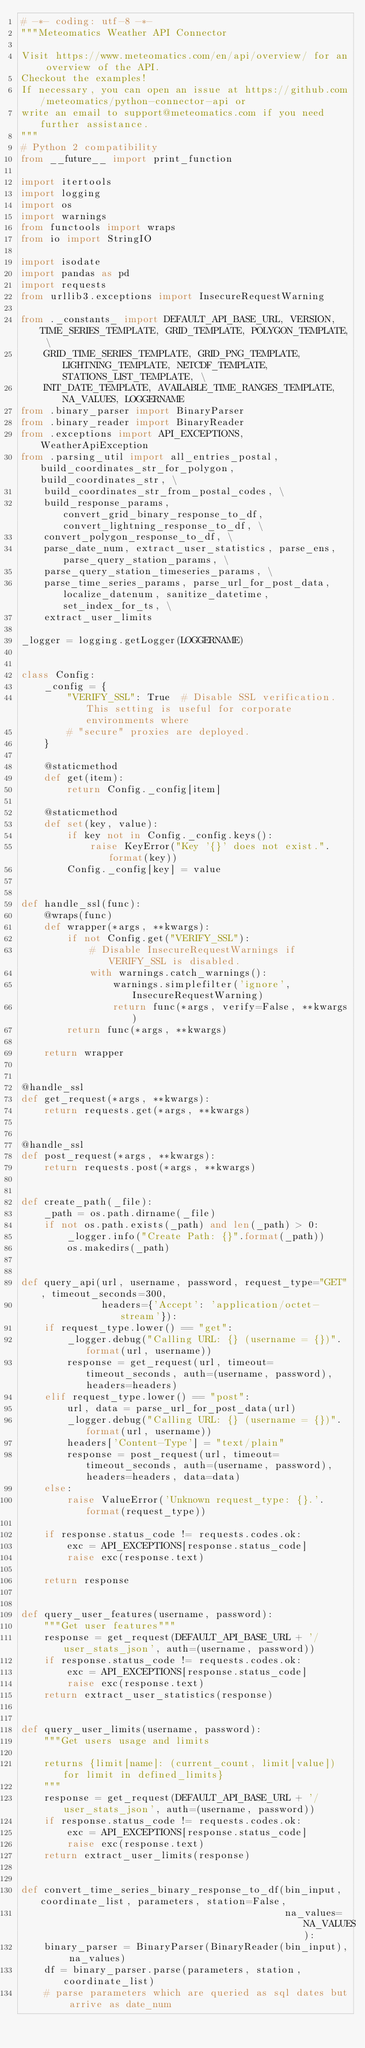<code> <loc_0><loc_0><loc_500><loc_500><_Python_># -*- coding: utf-8 -*-
"""Meteomatics Weather API Connector

Visit https://www.meteomatics.com/en/api/overview/ for an overview of the API.
Checkout the examples!
If necessary, you can open an issue at https://github.com/meteomatics/python-connector-api or
write an email to support@meteomatics.com if you need further assistance.
"""
# Python 2 compatibility
from __future__ import print_function

import itertools
import logging
import os
import warnings
from functools import wraps
from io import StringIO

import isodate
import pandas as pd
import requests
from urllib3.exceptions import InsecureRequestWarning

from ._constants_ import DEFAULT_API_BASE_URL, VERSION, TIME_SERIES_TEMPLATE, GRID_TEMPLATE, POLYGON_TEMPLATE, \
    GRID_TIME_SERIES_TEMPLATE, GRID_PNG_TEMPLATE, LIGHTNING_TEMPLATE, NETCDF_TEMPLATE, STATIONS_LIST_TEMPLATE, \
    INIT_DATE_TEMPLATE, AVAILABLE_TIME_RANGES_TEMPLATE, NA_VALUES, LOGGERNAME
from .binary_parser import BinaryParser
from .binary_reader import BinaryReader
from .exceptions import API_EXCEPTIONS, WeatherApiException
from .parsing_util import all_entries_postal, build_coordinates_str_for_polygon, build_coordinates_str, \
    build_coordinates_str_from_postal_codes, \
    build_response_params, convert_grid_binary_response_to_df, convert_lightning_response_to_df, \
    convert_polygon_response_to_df, \
    parse_date_num, extract_user_statistics, parse_ens, parse_query_station_params, \
    parse_query_station_timeseries_params, \
    parse_time_series_params, parse_url_for_post_data, localize_datenum, sanitize_datetime, set_index_for_ts, \
    extract_user_limits

_logger = logging.getLogger(LOGGERNAME)


class Config:
    _config = {
        "VERIFY_SSL": True  # Disable SSL verification. This setting is useful for corporate environments where
        # "secure" proxies are deployed.
    }

    @staticmethod
    def get(item):
        return Config._config[item]

    @staticmethod
    def set(key, value):
        if key not in Config._config.keys():
            raise KeyError("Key '{}' does not exist.".format(key))
        Config._config[key] = value


def handle_ssl(func):
    @wraps(func)
    def wrapper(*args, **kwargs):
        if not Config.get("VERIFY_SSL"):
            # Disable InsecureRequestWarnings if VERIFY_SSL is disabled.
            with warnings.catch_warnings():
                warnings.simplefilter('ignore', InsecureRequestWarning)
                return func(*args, verify=False, **kwargs)
        return func(*args, **kwargs)

    return wrapper


@handle_ssl
def get_request(*args, **kwargs):
    return requests.get(*args, **kwargs)


@handle_ssl
def post_request(*args, **kwargs):
    return requests.post(*args, **kwargs)


def create_path(_file):
    _path = os.path.dirname(_file)
    if not os.path.exists(_path) and len(_path) > 0:
        _logger.info("Create Path: {}".format(_path))
        os.makedirs(_path)


def query_api(url, username, password, request_type="GET", timeout_seconds=300,
              headers={'Accept': 'application/octet-stream'}):
    if request_type.lower() == "get":
        _logger.debug("Calling URL: {} (username = {})".format(url, username))
        response = get_request(url, timeout=timeout_seconds, auth=(username, password), headers=headers)
    elif request_type.lower() == "post":
        url, data = parse_url_for_post_data(url)
        _logger.debug("Calling URL: {} (username = {})".format(url, username))
        headers['Content-Type'] = "text/plain"
        response = post_request(url, timeout=timeout_seconds, auth=(username, password), headers=headers, data=data)
    else:
        raise ValueError('Unknown request_type: {}.'.format(request_type))

    if response.status_code != requests.codes.ok:
        exc = API_EXCEPTIONS[response.status_code]
        raise exc(response.text)

    return response


def query_user_features(username, password):
    """Get user features"""
    response = get_request(DEFAULT_API_BASE_URL + '/user_stats_json', auth=(username, password))
    if response.status_code != requests.codes.ok:
        exc = API_EXCEPTIONS[response.status_code]
        raise exc(response.text)
    return extract_user_statistics(response)


def query_user_limits(username, password):
    """Get users usage and limits

    returns {limit[name]: (current_count, limit[value]) for limit in defined_limits}
    """
    response = get_request(DEFAULT_API_BASE_URL + '/user_stats_json', auth=(username, password))
    if response.status_code != requests.codes.ok:
        exc = API_EXCEPTIONS[response.status_code]
        raise exc(response.text)
    return extract_user_limits(response)


def convert_time_series_binary_response_to_df(bin_input, coordinate_list, parameters, station=False,
                                              na_values=NA_VALUES):
    binary_parser = BinaryParser(BinaryReader(bin_input), na_values)
    df = binary_parser.parse(parameters, station, coordinate_list)
    # parse parameters which are queried as sql dates but arrive as date_num</code> 